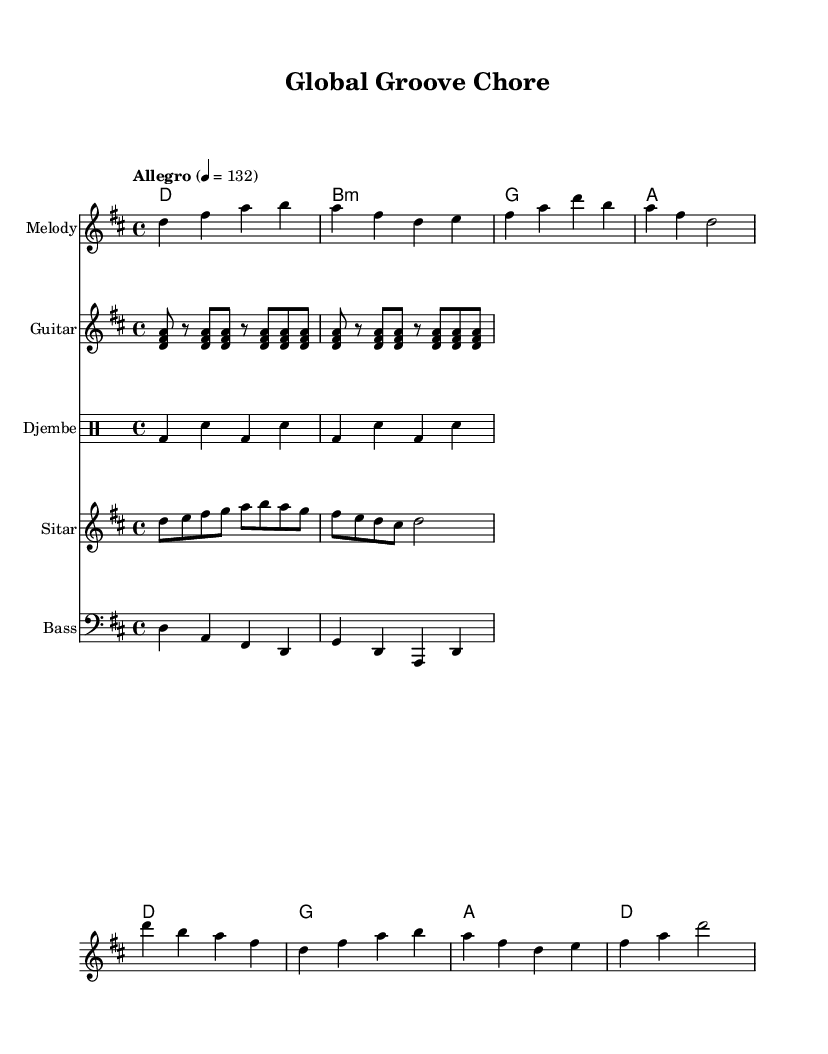What is the key signature of this music? The key signature is D major, which has two sharps (F# and C#). This can be determined from the \key d \major directive at the beginning of the code.
Answer: D major What is the time signature of this music? The time signature is 4/4, indicated by the \time 4/4 directive in the score. This means there are four beats per measure, and a quarter note gets one beat.
Answer: 4/4 What is the tempo marking for this piece? The tempo marking is Allegro, with a speed of 132 beats per minute, as indicated by the \tempo directive. This suggests a fast and lively pace.
Answer: Allegro How many measures are there in the melody? The melody, when counted, consists of eight measures. This can be observed by counting the segments of music divided by vertical bar lines in the melody section.
Answer: Eight What are the instruments included in this composition? The instruments featured in this composition are Melody, Guitar, Djembe, Sitar, and Bass. Each is specified by its own staff in the score, and the instrument names are labeled accordingly.
Answer: Melody, Guitar, Djembe, Sitar, Bass What kind of musical influences are shown in the harmonies? The harmonies reflect a mix of pop and world music, characterized by a straightforward chord progression (D, B minor, G, A) that is often found in upbeat music styles. This creates a vibrant background suitable for energizing chore activities.
Answer: Pop and world music What is the primary rhythm used in the djembe part? The primary rhythm for the djembe part is a repetitive pattern of bass and snare hits, shown as bd (bass drum) and sn (snare) quarters in the drummode section. This steady rhythm supports the upbeat feel of the piece.
Answer: Bass and snare 